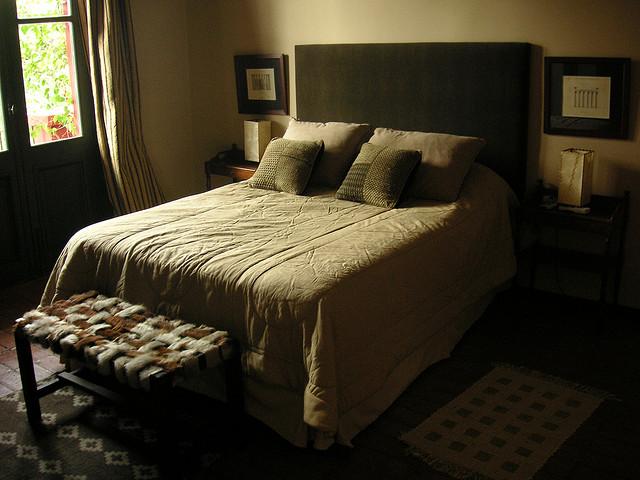Is it bedtime?
Be succinct. No. What color is the bed sheet?
Write a very short answer. Beige. Where is the source of light coming from?
Quick response, please. Window. 